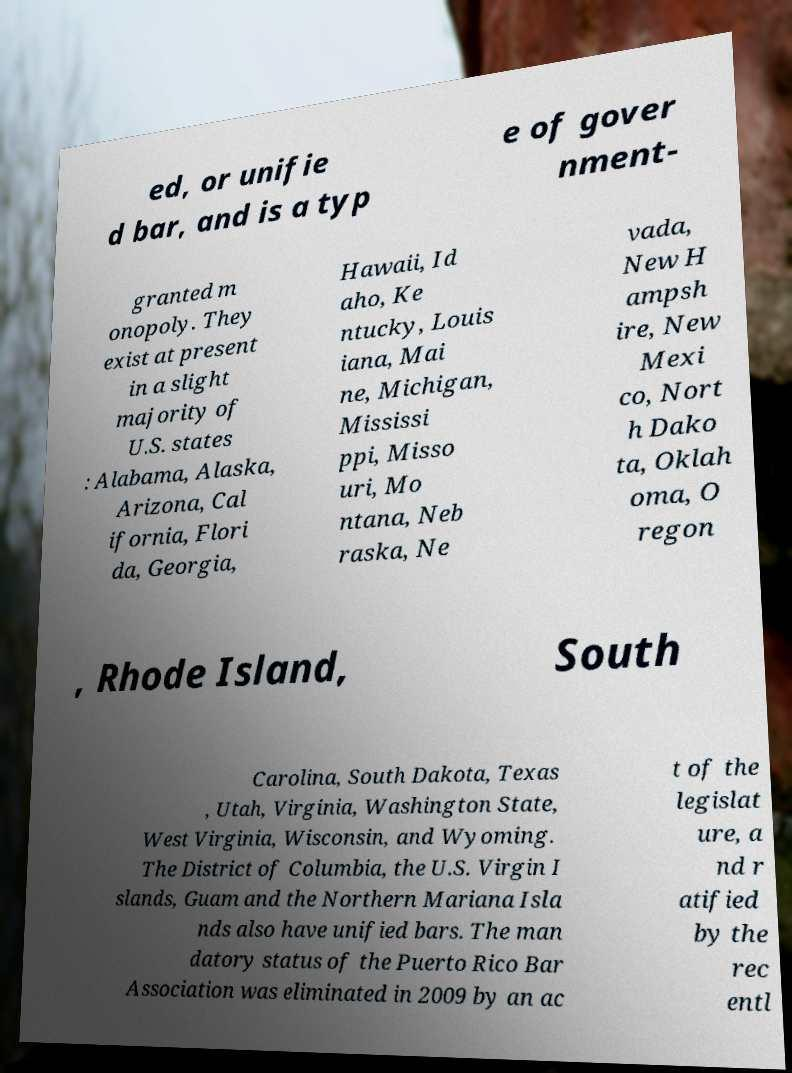Could you assist in decoding the text presented in this image and type it out clearly? ed, or unifie d bar, and is a typ e of gover nment- granted m onopoly. They exist at present in a slight majority of U.S. states : Alabama, Alaska, Arizona, Cal ifornia, Flori da, Georgia, Hawaii, Id aho, Ke ntucky, Louis iana, Mai ne, Michigan, Mississi ppi, Misso uri, Mo ntana, Neb raska, Ne vada, New H ampsh ire, New Mexi co, Nort h Dako ta, Oklah oma, O regon , Rhode Island, South Carolina, South Dakota, Texas , Utah, Virginia, Washington State, West Virginia, Wisconsin, and Wyoming. The District of Columbia, the U.S. Virgin I slands, Guam and the Northern Mariana Isla nds also have unified bars. The man datory status of the Puerto Rico Bar Association was eliminated in 2009 by an ac t of the legislat ure, a nd r atified by the rec entl 